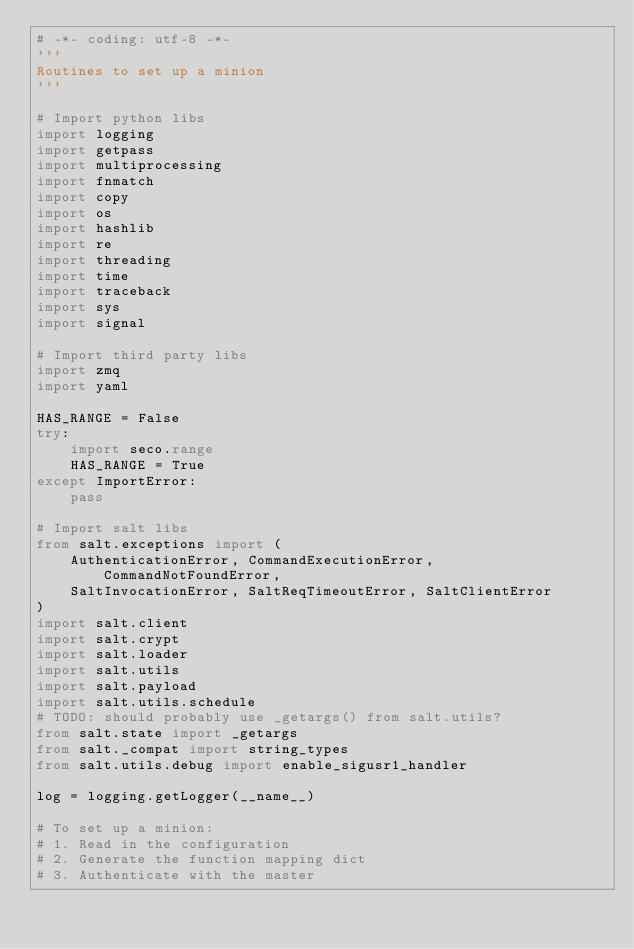Convert code to text. <code><loc_0><loc_0><loc_500><loc_500><_Python_># -*- coding: utf-8 -*-
'''
Routines to set up a minion
'''

# Import python libs
import logging
import getpass
import multiprocessing
import fnmatch
import copy
import os
import hashlib
import re
import threading
import time
import traceback
import sys
import signal

# Import third party libs
import zmq
import yaml

HAS_RANGE = False
try:
    import seco.range
    HAS_RANGE = True
except ImportError:
    pass

# Import salt libs
from salt.exceptions import (
    AuthenticationError, CommandExecutionError, CommandNotFoundError,
    SaltInvocationError, SaltReqTimeoutError, SaltClientError
)
import salt.client
import salt.crypt
import salt.loader
import salt.utils
import salt.payload
import salt.utils.schedule
# TODO: should probably use _getargs() from salt.utils?
from salt.state import _getargs
from salt._compat import string_types
from salt.utils.debug import enable_sigusr1_handler

log = logging.getLogger(__name__)

# To set up a minion:
# 1. Read in the configuration
# 2. Generate the function mapping dict
# 3. Authenticate with the master</code> 